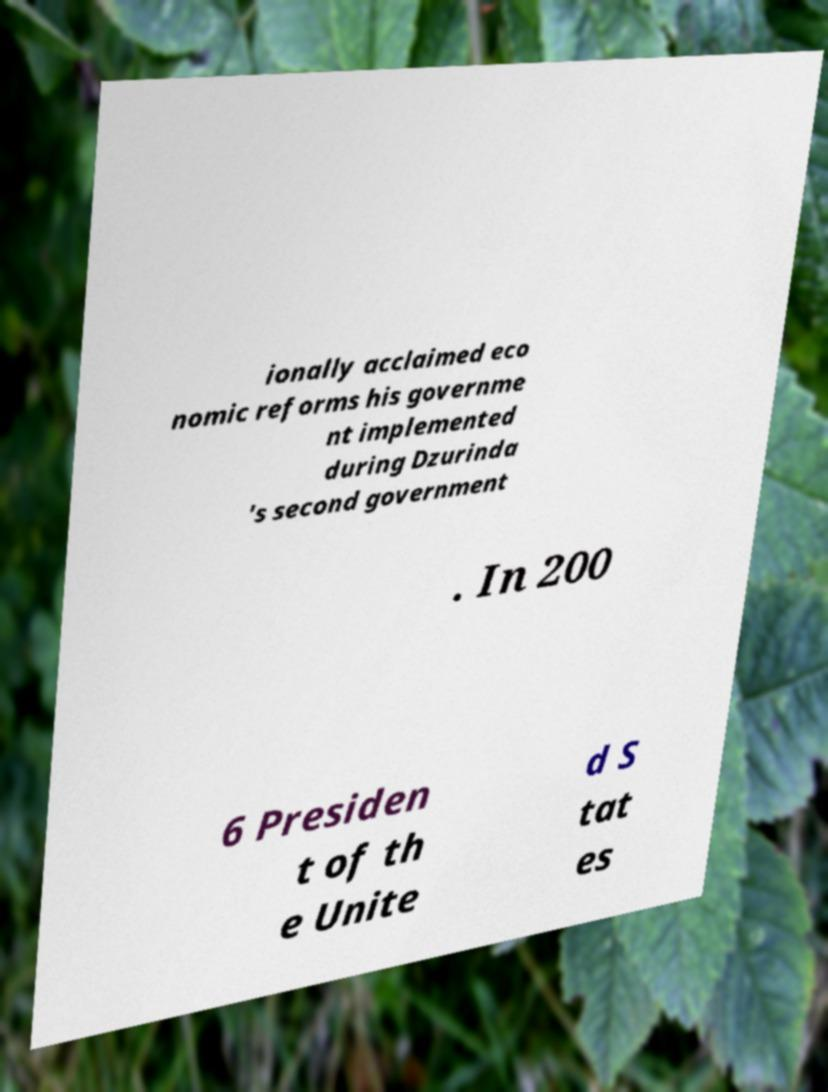There's text embedded in this image that I need extracted. Can you transcribe it verbatim? ionally acclaimed eco nomic reforms his governme nt implemented during Dzurinda 's second government . In 200 6 Presiden t of th e Unite d S tat es 